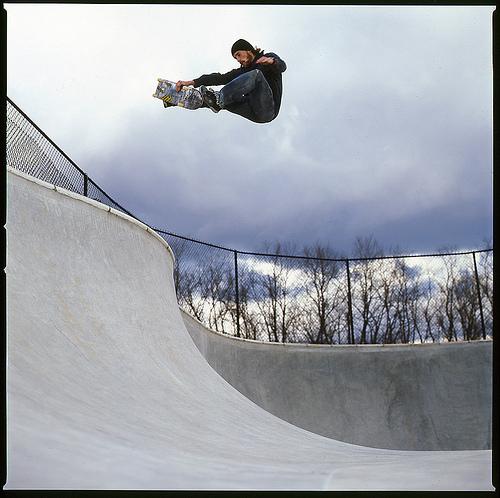What is the man holding on to?
Answer briefly. Skateboard. Is this person agile?
Keep it brief. Yes. Is this his first time skateboarding?
Write a very short answer. No. 